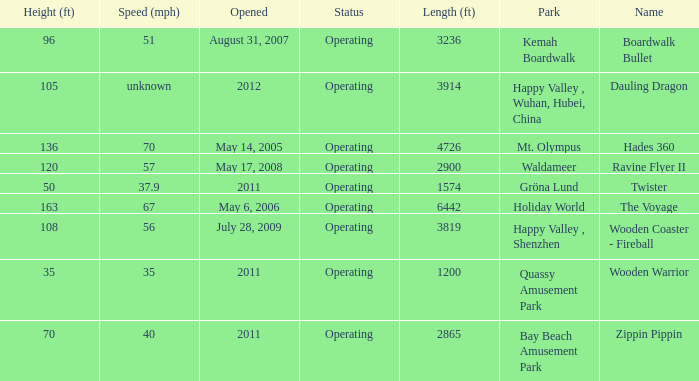In which park is boardwalk bullet situated? Kemah Boardwalk. 